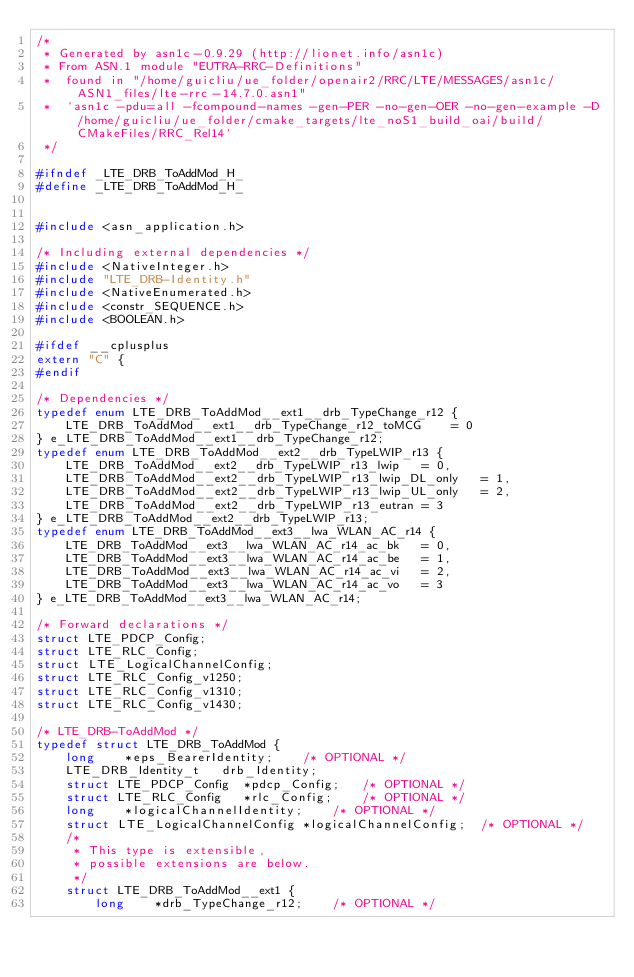<code> <loc_0><loc_0><loc_500><loc_500><_C_>/*
 * Generated by asn1c-0.9.29 (http://lionet.info/asn1c)
 * From ASN.1 module "EUTRA-RRC-Definitions"
 * 	found in "/home/guicliu/ue_folder/openair2/RRC/LTE/MESSAGES/asn1c/ASN1_files/lte-rrc-14.7.0.asn1"
 * 	`asn1c -pdu=all -fcompound-names -gen-PER -no-gen-OER -no-gen-example -D /home/guicliu/ue_folder/cmake_targets/lte_noS1_build_oai/build/CMakeFiles/RRC_Rel14`
 */

#ifndef	_LTE_DRB_ToAddMod_H_
#define	_LTE_DRB_ToAddMod_H_


#include <asn_application.h>

/* Including external dependencies */
#include <NativeInteger.h>
#include "LTE_DRB-Identity.h"
#include <NativeEnumerated.h>
#include <constr_SEQUENCE.h>
#include <BOOLEAN.h>

#ifdef __cplusplus
extern "C" {
#endif

/* Dependencies */
typedef enum LTE_DRB_ToAddMod__ext1__drb_TypeChange_r12 {
	LTE_DRB_ToAddMod__ext1__drb_TypeChange_r12_toMCG	= 0
} e_LTE_DRB_ToAddMod__ext1__drb_TypeChange_r12;
typedef enum LTE_DRB_ToAddMod__ext2__drb_TypeLWIP_r13 {
	LTE_DRB_ToAddMod__ext2__drb_TypeLWIP_r13_lwip	= 0,
	LTE_DRB_ToAddMod__ext2__drb_TypeLWIP_r13_lwip_DL_only	= 1,
	LTE_DRB_ToAddMod__ext2__drb_TypeLWIP_r13_lwip_UL_only	= 2,
	LTE_DRB_ToAddMod__ext2__drb_TypeLWIP_r13_eutran	= 3
} e_LTE_DRB_ToAddMod__ext2__drb_TypeLWIP_r13;
typedef enum LTE_DRB_ToAddMod__ext3__lwa_WLAN_AC_r14 {
	LTE_DRB_ToAddMod__ext3__lwa_WLAN_AC_r14_ac_bk	= 0,
	LTE_DRB_ToAddMod__ext3__lwa_WLAN_AC_r14_ac_be	= 1,
	LTE_DRB_ToAddMod__ext3__lwa_WLAN_AC_r14_ac_vi	= 2,
	LTE_DRB_ToAddMod__ext3__lwa_WLAN_AC_r14_ac_vo	= 3
} e_LTE_DRB_ToAddMod__ext3__lwa_WLAN_AC_r14;

/* Forward declarations */
struct LTE_PDCP_Config;
struct LTE_RLC_Config;
struct LTE_LogicalChannelConfig;
struct LTE_RLC_Config_v1250;
struct LTE_RLC_Config_v1310;
struct LTE_RLC_Config_v1430;

/* LTE_DRB-ToAddMod */
typedef struct LTE_DRB_ToAddMod {
	long	*eps_BearerIdentity;	/* OPTIONAL */
	LTE_DRB_Identity_t	 drb_Identity;
	struct LTE_PDCP_Config	*pdcp_Config;	/* OPTIONAL */
	struct LTE_RLC_Config	*rlc_Config;	/* OPTIONAL */
	long	*logicalChannelIdentity;	/* OPTIONAL */
	struct LTE_LogicalChannelConfig	*logicalChannelConfig;	/* OPTIONAL */
	/*
	 * This type is extensible,
	 * possible extensions are below.
	 */
	struct LTE_DRB_ToAddMod__ext1 {
		long	*drb_TypeChange_r12;	/* OPTIONAL */</code> 